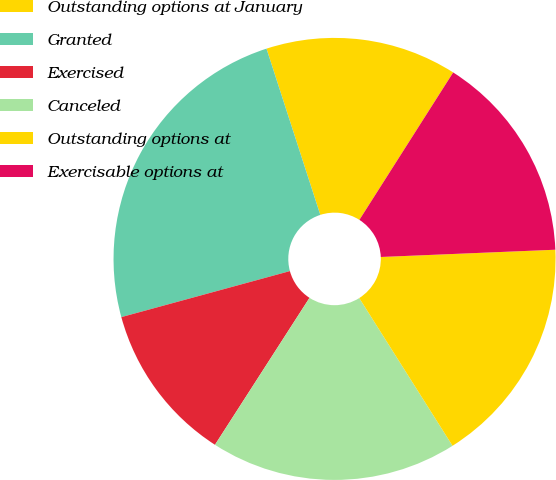Convert chart. <chart><loc_0><loc_0><loc_500><loc_500><pie_chart><fcel>Outstanding options at January<fcel>Granted<fcel>Exercised<fcel>Canceled<fcel>Outstanding options at<fcel>Exercisable options at<nl><fcel>14.0%<fcel>24.26%<fcel>11.66%<fcel>18.06%<fcel>16.7%<fcel>15.32%<nl></chart> 